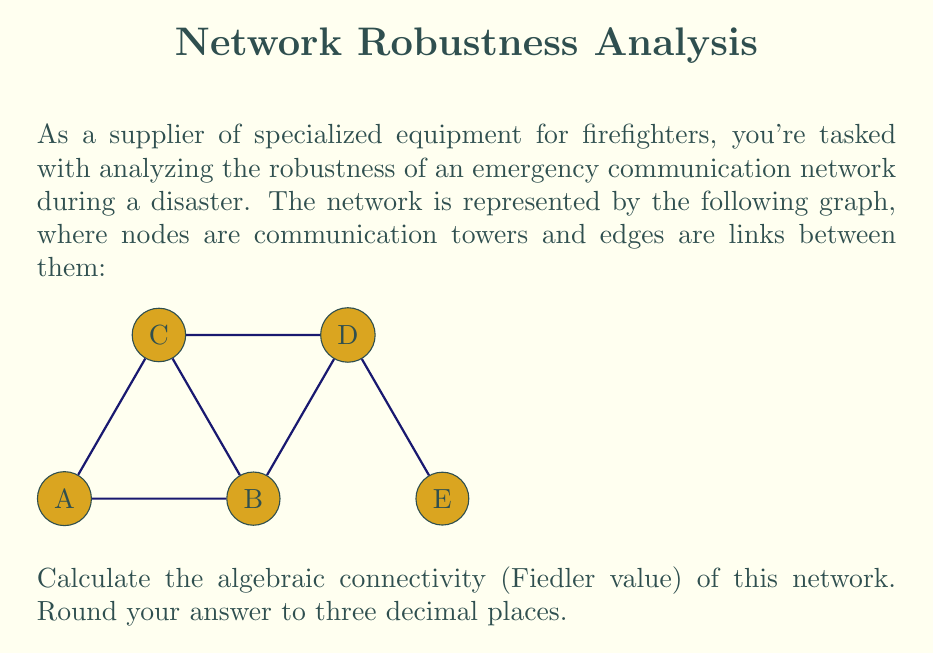Can you solve this math problem? To find the algebraic connectivity of the graph, we need to follow these steps:

1) First, construct the Laplacian matrix $L$ of the graph. For a graph with $n$ vertices, $L = D - A$, where $D$ is the degree matrix and $A$ is the adjacency matrix.

2) The degree matrix $D$ is:
   $$D = \begin{bmatrix}
   2 & 0 & 0 & 0 & 0 \\
   0 & 3 & 0 & 0 & 0 \\
   0 & 0 & 3 & 0 & 0 \\
   0 & 0 & 0 & 3 & 0 \\
   0 & 0 & 0 & 0 & 1
   \end{bmatrix}$$

3) The adjacency matrix $A$ is:
   $$A = \begin{bmatrix}
   0 & 1 & 1 & 0 & 0 \\
   1 & 0 & 1 & 1 & 0 \\
   1 & 1 & 0 & 1 & 0 \\
   0 & 1 & 1 & 0 & 1 \\
   0 & 0 & 0 & 1 & 0
   \end{bmatrix}$$

4) The Laplacian matrix $L = D - A$ is:
   $$L = \begin{bmatrix}
   2 & -1 & -1 & 0 & 0 \\
   -1 & 3 & -1 & -1 & 0 \\
   -1 & -1 & 3 & -1 & 0 \\
   0 & -1 & -1 & 3 & -1 \\
   0 & 0 & 0 & -1 & 1
   \end{bmatrix}$$

5) The algebraic connectivity is the second smallest eigenvalue of $L$. We can find the eigenvalues using a computer algebra system or numerical methods.

6) The eigenvalues of $L$ are approximately:
   $0, 0.585, 2.000, 3.000, 4.415$

7) The second smallest eigenvalue, rounded to three decimal places, is 0.585.

This value, known as the Fiedler value, provides a measure of the graph's connectivity. A higher value indicates better connectivity and more robustness against node/edge failures.
Answer: 0.585 